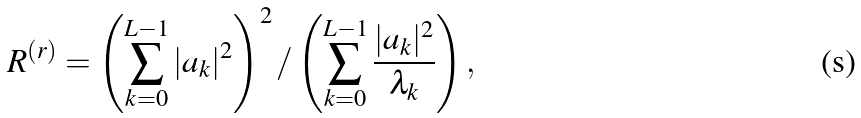<formula> <loc_0><loc_0><loc_500><loc_500>R ^ { ( r ) } = \left ( \sum _ { k = 0 } ^ { L - 1 } | a _ { k } | ^ { 2 } \right ) ^ { 2 } / \left ( \sum _ { k = 0 } ^ { L - 1 } \frac { | a _ { k } | ^ { 2 } } { \lambda _ { k } } \right ) ,</formula> 